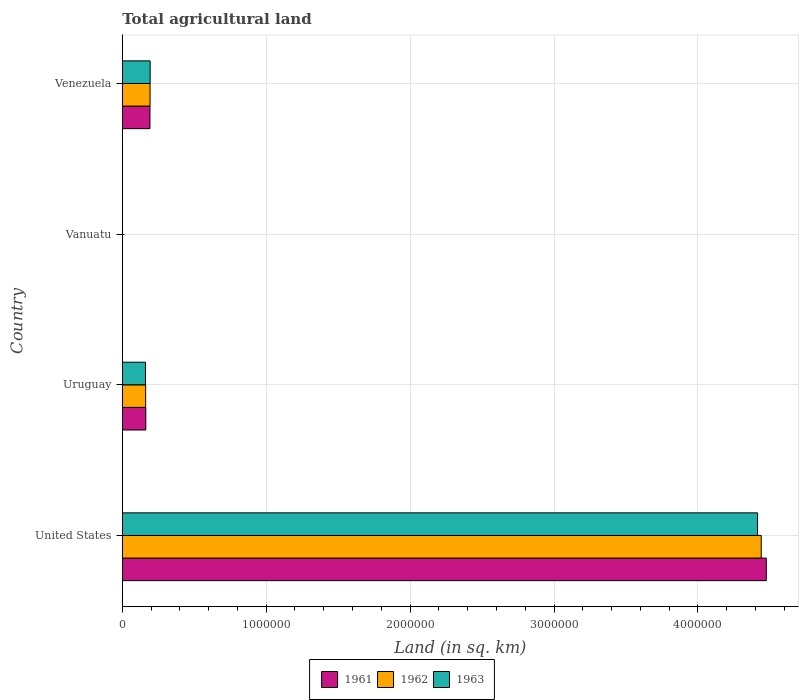How many different coloured bars are there?
Give a very brief answer. 3. How many groups of bars are there?
Keep it short and to the point. 4. Are the number of bars per tick equal to the number of legend labels?
Ensure brevity in your answer.  Yes. Are the number of bars on each tick of the Y-axis equal?
Offer a very short reply. Yes. What is the label of the 2nd group of bars from the top?
Provide a succinct answer. Vanuatu. What is the total agricultural land in 1962 in Uruguay?
Your answer should be very brief. 1.62e+05. Across all countries, what is the maximum total agricultural land in 1963?
Provide a succinct answer. 4.41e+06. Across all countries, what is the minimum total agricultural land in 1961?
Provide a short and direct response. 1050. In which country was the total agricultural land in 1963 maximum?
Your response must be concise. United States. In which country was the total agricultural land in 1961 minimum?
Your answer should be compact. Vanuatu. What is the total total agricultural land in 1963 in the graph?
Ensure brevity in your answer.  4.77e+06. What is the difference between the total agricultural land in 1961 in Uruguay and that in Vanuatu?
Offer a terse response. 1.62e+05. What is the difference between the total agricultural land in 1961 in Venezuela and the total agricultural land in 1962 in Uruguay?
Provide a succinct answer. 2.98e+04. What is the average total agricultural land in 1961 per country?
Your response must be concise. 1.21e+06. In how many countries, is the total agricultural land in 1961 greater than 2800000 sq.km?
Ensure brevity in your answer.  1. What is the ratio of the total agricultural land in 1962 in Uruguay to that in Vanuatu?
Ensure brevity in your answer.  154.75. Is the total agricultural land in 1963 in Uruguay less than that in Vanuatu?
Offer a very short reply. No. What is the difference between the highest and the second highest total agricultural land in 1961?
Your response must be concise. 4.28e+06. What is the difference between the highest and the lowest total agricultural land in 1963?
Give a very brief answer. 4.41e+06. Is the sum of the total agricultural land in 1963 in United States and Vanuatu greater than the maximum total agricultural land in 1961 across all countries?
Provide a short and direct response. No. What does the 2nd bar from the top in Uruguay represents?
Provide a short and direct response. 1962. Is it the case that in every country, the sum of the total agricultural land in 1963 and total agricultural land in 1961 is greater than the total agricultural land in 1962?
Your response must be concise. Yes. How many bars are there?
Provide a succinct answer. 12. Are all the bars in the graph horizontal?
Give a very brief answer. Yes. Are the values on the major ticks of X-axis written in scientific E-notation?
Offer a very short reply. No. Does the graph contain any zero values?
Ensure brevity in your answer.  No. How many legend labels are there?
Offer a terse response. 3. What is the title of the graph?
Your response must be concise. Total agricultural land. Does "1972" appear as one of the legend labels in the graph?
Provide a short and direct response. No. What is the label or title of the X-axis?
Make the answer very short. Land (in sq. km). What is the Land (in sq. km) of 1961 in United States?
Ensure brevity in your answer.  4.48e+06. What is the Land (in sq. km) in 1962 in United States?
Your response must be concise. 4.44e+06. What is the Land (in sq. km) in 1963 in United States?
Keep it short and to the point. 4.41e+06. What is the Land (in sq. km) of 1961 in Uruguay?
Your answer should be compact. 1.64e+05. What is the Land (in sq. km) of 1962 in Uruguay?
Ensure brevity in your answer.  1.62e+05. What is the Land (in sq. km) of 1963 in Uruguay?
Offer a very short reply. 1.61e+05. What is the Land (in sq. km) of 1961 in Vanuatu?
Make the answer very short. 1050. What is the Land (in sq. km) of 1962 in Vanuatu?
Ensure brevity in your answer.  1050. What is the Land (in sq. km) of 1963 in Vanuatu?
Offer a terse response. 1050. What is the Land (in sq. km) of 1961 in Venezuela?
Your answer should be very brief. 1.92e+05. What is the Land (in sq. km) of 1962 in Venezuela?
Offer a very short reply. 1.93e+05. What is the Land (in sq. km) of 1963 in Venezuela?
Your answer should be compact. 1.94e+05. Across all countries, what is the maximum Land (in sq. km) in 1961?
Offer a very short reply. 4.48e+06. Across all countries, what is the maximum Land (in sq. km) of 1962?
Give a very brief answer. 4.44e+06. Across all countries, what is the maximum Land (in sq. km) in 1963?
Your answer should be very brief. 4.41e+06. Across all countries, what is the minimum Land (in sq. km) in 1961?
Offer a terse response. 1050. Across all countries, what is the minimum Land (in sq. km) in 1962?
Provide a short and direct response. 1050. Across all countries, what is the minimum Land (in sq. km) of 1963?
Keep it short and to the point. 1050. What is the total Land (in sq. km) of 1961 in the graph?
Offer a very short reply. 4.83e+06. What is the total Land (in sq. km) of 1962 in the graph?
Your response must be concise. 4.80e+06. What is the total Land (in sq. km) in 1963 in the graph?
Provide a short and direct response. 4.77e+06. What is the difference between the Land (in sq. km) of 1961 in United States and that in Uruguay?
Your answer should be very brief. 4.31e+06. What is the difference between the Land (in sq. km) of 1962 in United States and that in Uruguay?
Provide a short and direct response. 4.28e+06. What is the difference between the Land (in sq. km) of 1963 in United States and that in Uruguay?
Keep it short and to the point. 4.25e+06. What is the difference between the Land (in sq. km) in 1961 in United States and that in Vanuatu?
Offer a terse response. 4.47e+06. What is the difference between the Land (in sq. km) in 1962 in United States and that in Vanuatu?
Offer a very short reply. 4.44e+06. What is the difference between the Land (in sq. km) in 1963 in United States and that in Vanuatu?
Offer a very short reply. 4.41e+06. What is the difference between the Land (in sq. km) of 1961 in United States and that in Venezuela?
Ensure brevity in your answer.  4.28e+06. What is the difference between the Land (in sq. km) of 1962 in United States and that in Venezuela?
Your answer should be compact. 4.25e+06. What is the difference between the Land (in sq. km) in 1963 in United States and that in Venezuela?
Give a very brief answer. 4.22e+06. What is the difference between the Land (in sq. km) of 1961 in Uruguay and that in Vanuatu?
Provide a short and direct response. 1.62e+05. What is the difference between the Land (in sq. km) in 1962 in Uruguay and that in Vanuatu?
Offer a very short reply. 1.61e+05. What is the difference between the Land (in sq. km) of 1963 in Uruguay and that in Vanuatu?
Keep it short and to the point. 1.60e+05. What is the difference between the Land (in sq. km) in 1961 in Uruguay and that in Venezuela?
Keep it short and to the point. -2.88e+04. What is the difference between the Land (in sq. km) in 1962 in Uruguay and that in Venezuela?
Offer a very short reply. -3.05e+04. What is the difference between the Land (in sq. km) of 1963 in Uruguay and that in Venezuela?
Offer a very short reply. -3.23e+04. What is the difference between the Land (in sq. km) of 1961 in Vanuatu and that in Venezuela?
Offer a very short reply. -1.91e+05. What is the difference between the Land (in sq. km) in 1962 in Vanuatu and that in Venezuela?
Offer a terse response. -1.92e+05. What is the difference between the Land (in sq. km) of 1963 in Vanuatu and that in Venezuela?
Give a very brief answer. -1.93e+05. What is the difference between the Land (in sq. km) of 1961 in United States and the Land (in sq. km) of 1962 in Uruguay?
Offer a very short reply. 4.31e+06. What is the difference between the Land (in sq. km) in 1961 in United States and the Land (in sq. km) in 1963 in Uruguay?
Provide a succinct answer. 4.31e+06. What is the difference between the Land (in sq. km) of 1962 in United States and the Land (in sq. km) of 1963 in Uruguay?
Provide a short and direct response. 4.28e+06. What is the difference between the Land (in sq. km) of 1961 in United States and the Land (in sq. km) of 1962 in Vanuatu?
Keep it short and to the point. 4.47e+06. What is the difference between the Land (in sq. km) of 1961 in United States and the Land (in sq. km) of 1963 in Vanuatu?
Provide a short and direct response. 4.47e+06. What is the difference between the Land (in sq. km) of 1962 in United States and the Land (in sq. km) of 1963 in Vanuatu?
Keep it short and to the point. 4.44e+06. What is the difference between the Land (in sq. km) of 1961 in United States and the Land (in sq. km) of 1962 in Venezuela?
Ensure brevity in your answer.  4.28e+06. What is the difference between the Land (in sq. km) of 1961 in United States and the Land (in sq. km) of 1963 in Venezuela?
Make the answer very short. 4.28e+06. What is the difference between the Land (in sq. km) in 1962 in United States and the Land (in sq. km) in 1963 in Venezuela?
Your answer should be very brief. 4.25e+06. What is the difference between the Land (in sq. km) of 1961 in Uruguay and the Land (in sq. km) of 1962 in Vanuatu?
Your response must be concise. 1.62e+05. What is the difference between the Land (in sq. km) of 1961 in Uruguay and the Land (in sq. km) of 1963 in Vanuatu?
Provide a succinct answer. 1.62e+05. What is the difference between the Land (in sq. km) in 1962 in Uruguay and the Land (in sq. km) in 1963 in Vanuatu?
Your answer should be very brief. 1.61e+05. What is the difference between the Land (in sq. km) in 1961 in Uruguay and the Land (in sq. km) in 1962 in Venezuela?
Offer a terse response. -2.95e+04. What is the difference between the Land (in sq. km) in 1961 in Uruguay and the Land (in sq. km) in 1963 in Venezuela?
Provide a succinct answer. -3.02e+04. What is the difference between the Land (in sq. km) of 1962 in Uruguay and the Land (in sq. km) of 1963 in Venezuela?
Make the answer very short. -3.12e+04. What is the difference between the Land (in sq. km) of 1961 in Vanuatu and the Land (in sq. km) of 1962 in Venezuela?
Keep it short and to the point. -1.92e+05. What is the difference between the Land (in sq. km) in 1961 in Vanuatu and the Land (in sq. km) in 1963 in Venezuela?
Keep it short and to the point. -1.93e+05. What is the difference between the Land (in sq. km) in 1962 in Vanuatu and the Land (in sq. km) in 1963 in Venezuela?
Make the answer very short. -1.93e+05. What is the average Land (in sq. km) in 1961 per country?
Offer a very short reply. 1.21e+06. What is the average Land (in sq. km) in 1962 per country?
Your answer should be very brief. 1.20e+06. What is the average Land (in sq. km) in 1963 per country?
Your answer should be compact. 1.19e+06. What is the difference between the Land (in sq. km) in 1961 and Land (in sq. km) in 1962 in United States?
Your response must be concise. 3.52e+04. What is the difference between the Land (in sq. km) of 1961 and Land (in sq. km) of 1963 in United States?
Ensure brevity in your answer.  6.07e+04. What is the difference between the Land (in sq. km) of 1962 and Land (in sq. km) of 1963 in United States?
Offer a very short reply. 2.55e+04. What is the difference between the Land (in sq. km) in 1961 and Land (in sq. km) in 1962 in Uruguay?
Keep it short and to the point. 1050. What is the difference between the Land (in sq. km) of 1961 and Land (in sq. km) of 1963 in Uruguay?
Keep it short and to the point. 2130. What is the difference between the Land (in sq. km) in 1962 and Land (in sq. km) in 1963 in Uruguay?
Make the answer very short. 1080. What is the difference between the Land (in sq. km) of 1961 and Land (in sq. km) of 1963 in Vanuatu?
Make the answer very short. 0. What is the difference between the Land (in sq. km) in 1961 and Land (in sq. km) in 1962 in Venezuela?
Provide a short and direct response. -700. What is the difference between the Land (in sq. km) of 1961 and Land (in sq. km) of 1963 in Venezuela?
Offer a terse response. -1400. What is the difference between the Land (in sq. km) of 1962 and Land (in sq. km) of 1963 in Venezuela?
Keep it short and to the point. -700. What is the ratio of the Land (in sq. km) of 1961 in United States to that in Uruguay?
Provide a short and direct response. 27.36. What is the ratio of the Land (in sq. km) in 1962 in United States to that in Uruguay?
Your answer should be compact. 27.32. What is the ratio of the Land (in sq. km) in 1963 in United States to that in Uruguay?
Your answer should be compact. 27.35. What is the ratio of the Land (in sq. km) of 1961 in United States to that in Vanuatu?
Provide a short and direct response. 4261.99. What is the ratio of the Land (in sq. km) of 1962 in United States to that in Vanuatu?
Make the answer very short. 4228.49. What is the ratio of the Land (in sq. km) in 1963 in United States to that in Vanuatu?
Make the answer very short. 4204.22. What is the ratio of the Land (in sq. km) in 1961 in United States to that in Venezuela?
Give a very brief answer. 23.27. What is the ratio of the Land (in sq. km) in 1962 in United States to that in Venezuela?
Your answer should be very brief. 23. What is the ratio of the Land (in sq. km) in 1963 in United States to that in Venezuela?
Make the answer very short. 22.79. What is the ratio of the Land (in sq. km) in 1961 in Uruguay to that in Vanuatu?
Make the answer very short. 155.75. What is the ratio of the Land (in sq. km) of 1962 in Uruguay to that in Vanuatu?
Your response must be concise. 154.75. What is the ratio of the Land (in sq. km) in 1963 in Uruguay to that in Vanuatu?
Make the answer very short. 153.72. What is the ratio of the Land (in sq. km) of 1961 in Uruguay to that in Venezuela?
Keep it short and to the point. 0.85. What is the ratio of the Land (in sq. km) in 1962 in Uruguay to that in Venezuela?
Provide a short and direct response. 0.84. What is the ratio of the Land (in sq. km) in 1963 in Uruguay to that in Venezuela?
Keep it short and to the point. 0.83. What is the ratio of the Land (in sq. km) in 1961 in Vanuatu to that in Venezuela?
Provide a succinct answer. 0.01. What is the ratio of the Land (in sq. km) of 1962 in Vanuatu to that in Venezuela?
Make the answer very short. 0.01. What is the ratio of the Land (in sq. km) in 1963 in Vanuatu to that in Venezuela?
Offer a terse response. 0.01. What is the difference between the highest and the second highest Land (in sq. km) in 1961?
Keep it short and to the point. 4.28e+06. What is the difference between the highest and the second highest Land (in sq. km) of 1962?
Provide a succinct answer. 4.25e+06. What is the difference between the highest and the second highest Land (in sq. km) of 1963?
Give a very brief answer. 4.22e+06. What is the difference between the highest and the lowest Land (in sq. km) of 1961?
Ensure brevity in your answer.  4.47e+06. What is the difference between the highest and the lowest Land (in sq. km) in 1962?
Make the answer very short. 4.44e+06. What is the difference between the highest and the lowest Land (in sq. km) in 1963?
Provide a succinct answer. 4.41e+06. 